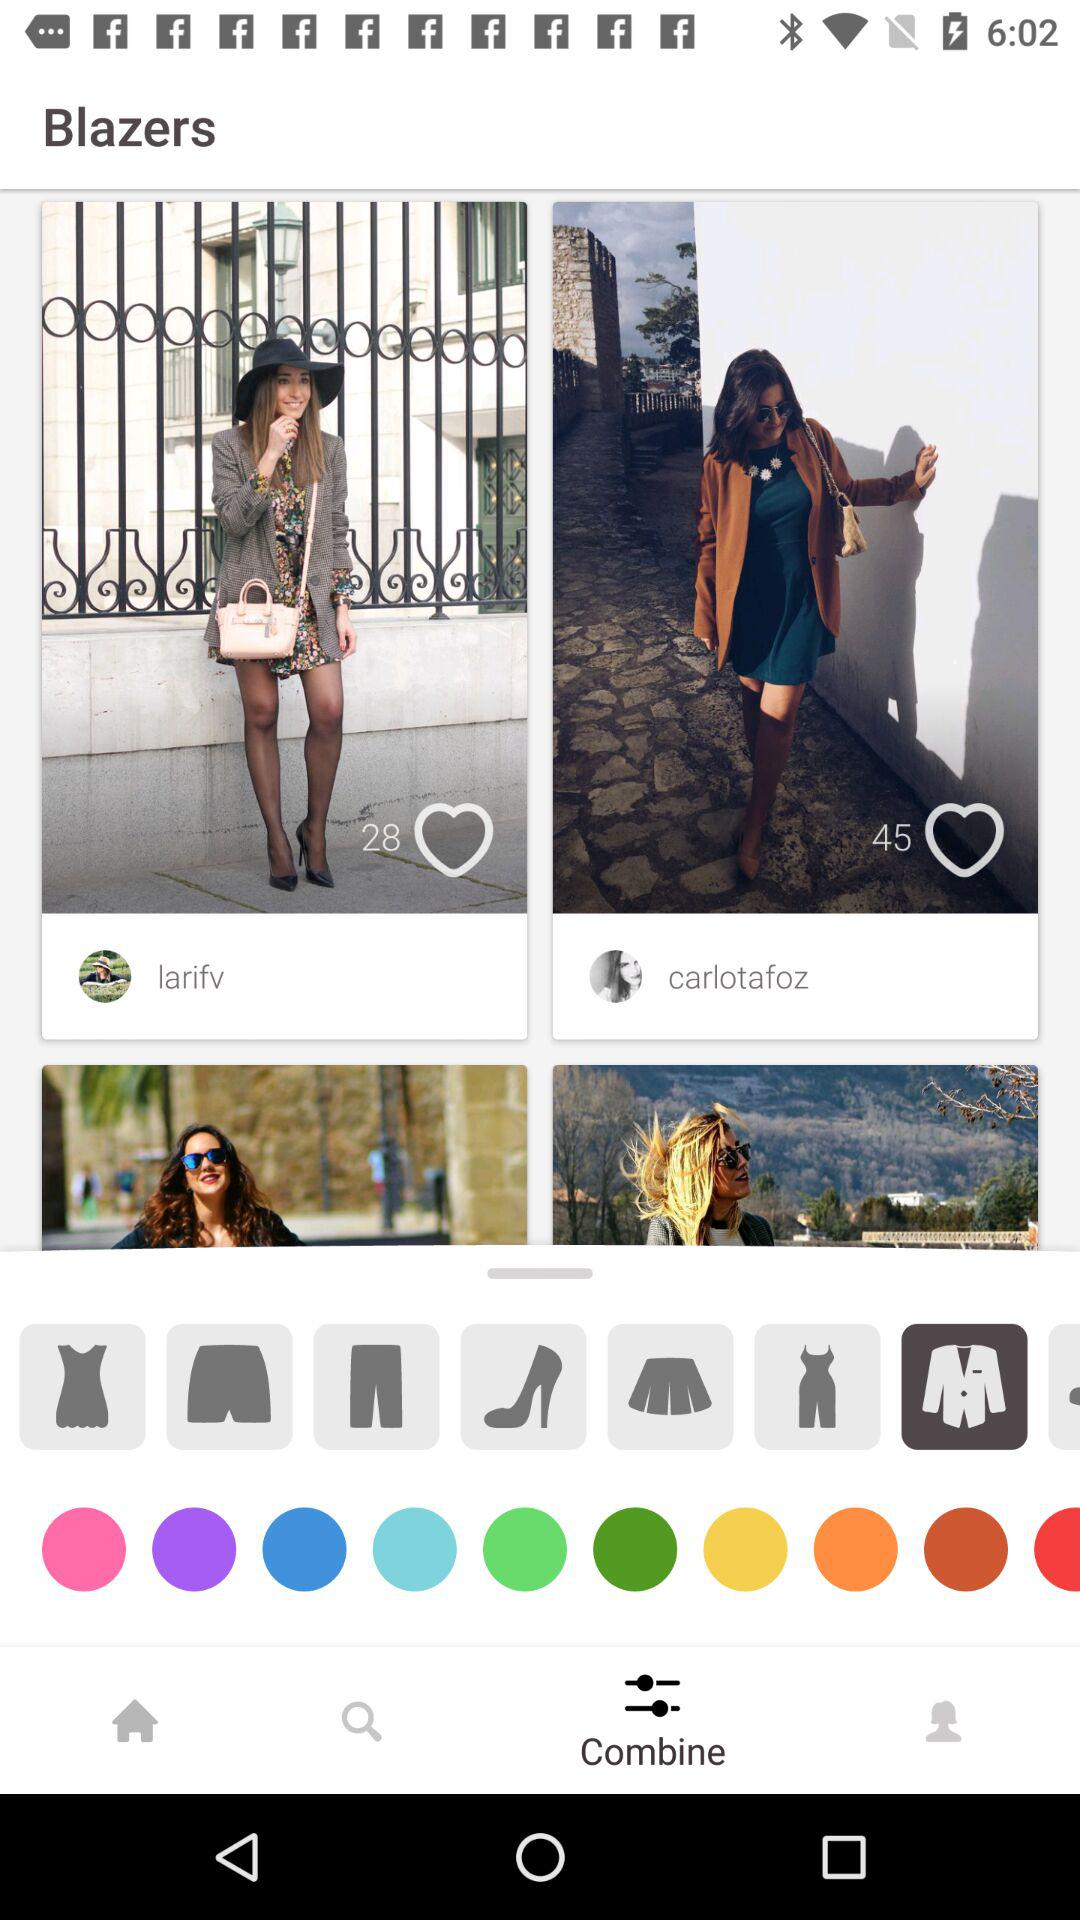What is the number of likes of the image posted by "larifv"? The number of likes is 28. 